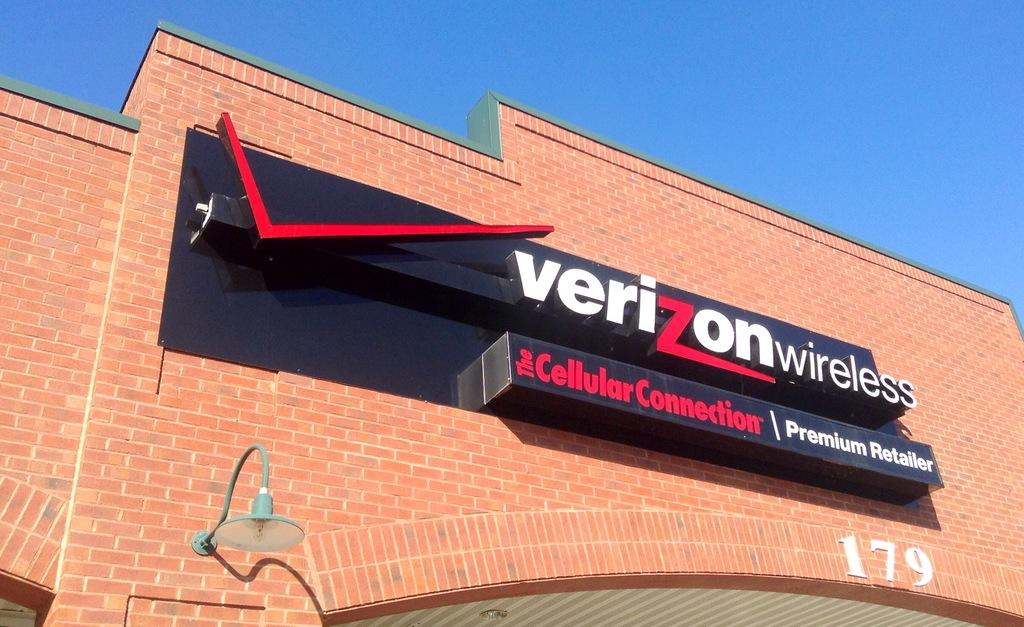<image>
Provide a brief description of the given image. Black Verizon Wireless sign on a brown building. 